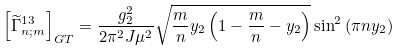<formula> <loc_0><loc_0><loc_500><loc_500>\left [ \widetilde { \Gamma } _ { n ; m } ^ { 1 3 } \right ] _ { G T } = \frac { g _ { 2 } ^ { 2 } } { 2 \pi ^ { 2 } J \mu ^ { 2 } } \sqrt { \frac { m } { n } y _ { 2 } \left ( 1 - \frac { m } { n } - y _ { 2 } \right ) } \sin ^ { 2 } \left ( \pi n y _ { 2 } \right )</formula> 